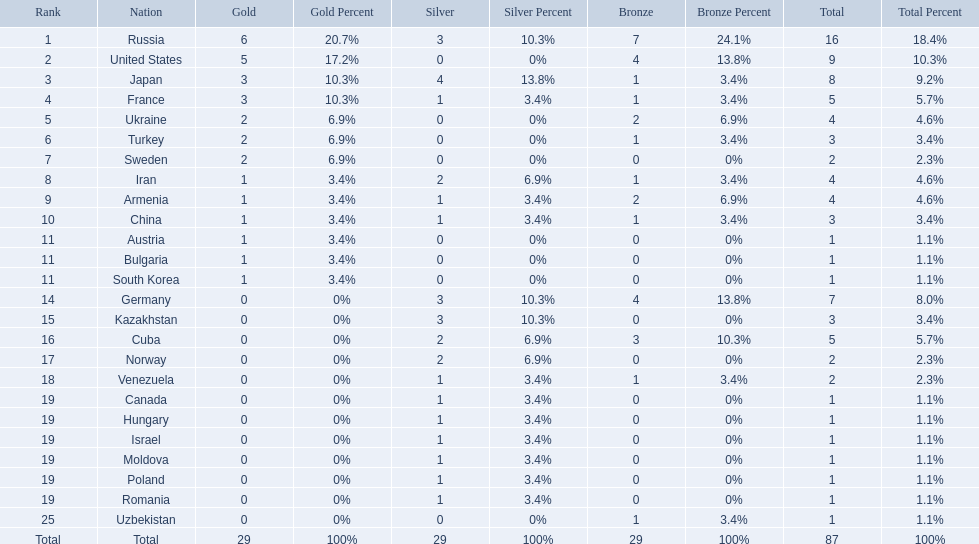What were the nations that participated in the 1995 world wrestling championships? Russia, United States, Japan, France, Ukraine, Turkey, Sweden, Iran, Armenia, China, Austria, Bulgaria, South Korea, Germany, Kazakhstan, Cuba, Norway, Venezuela, Canada, Hungary, Israel, Moldova, Poland, Romania, Uzbekistan. How many gold medals did the united states earn in the championship? 5. What amount of medals earner was greater than this value? 6. What country earned these medals? Russia. 